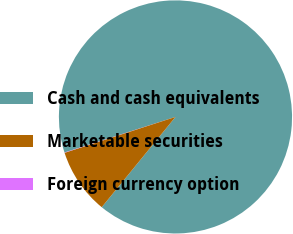<chart> <loc_0><loc_0><loc_500><loc_500><pie_chart><fcel>Cash and cash equivalents<fcel>Marketable securities<fcel>Foreign currency option<nl><fcel>90.85%<fcel>9.12%<fcel>0.04%<nl></chart> 